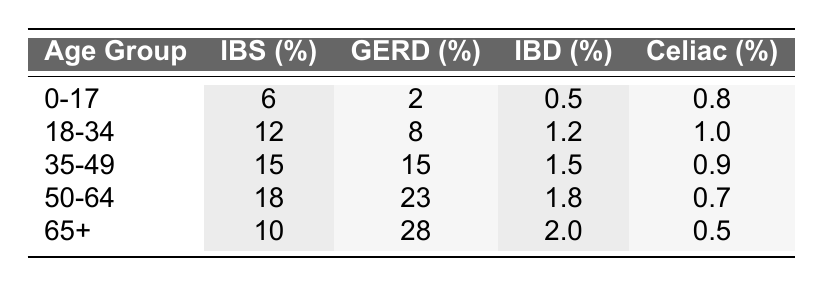What is the prevalence of Irritable Bowel Syndrome in the age group 35-49? In the table, under the column for Irritable Bowel Syndrome for the age group 35-49, the value is 15%.
Answer: 15% Which age group has the highest percentage of Gastroesophageal Reflux Disease? The table shows that the age group 65+ has the highest percentage at 28%.
Answer: 65+ Is the prevalence of Celiac Disease higher in the age group 0-17 compared to 18-34? Looking at the Celiac Disease column for age groups 0-17 and 18-34, the percentages are 0.8% and 1.0%, respectively. Since 0.8% is less than 1.0%, the answer is no.
Answer: No What is the average percentage of Inflammatory Bowel Disease across all age groups? To find the average, sum the percentages (0.5 + 1.2 + 1.5 + 1.8 + 2.0) = 7.0%, then divide by the number of age groups (5). Thus, the average is 7.0% / 5 = 1.4%.
Answer: 1.4% True or False: The prevalence of Irritable Bowel Syndrome in the 50-64 age group is higher than in the 18-34 age group. Checking the table, the percentage for 50-64 is 18%, while for 18-34 it is 12%. Since 18% is indeed higher than 12%, the statement is true.
Answer: True How much higher is the percentage of Gastroesophageal Reflux Disease in the 50-64 age group compared to the 0-17 age group? From the table, the percentage for the 50-64 age group is 23% and for the 0-17 age group it is 2%. The difference is 23% - 2% = 21%.
Answer: 21% Which age group shows the lowest prevalence of Celiac Disease? The table indicates that the age group 50-64 has the lowest prevalence of Celiac Disease at 0.7%.
Answer: 50-64 How does the prevalence of Inflammatory Bowel Disease change from the age group 18-34 to 35-49? In the table, the percentage for Inflammatory Bowel Disease in the 18-34 age group is 1.2%, and for the 35-49 age group it is 1.5%. The change is 1.5% - 1.2% = 0.3%, indicating an increase.
Answer: Increase of 0.3% 